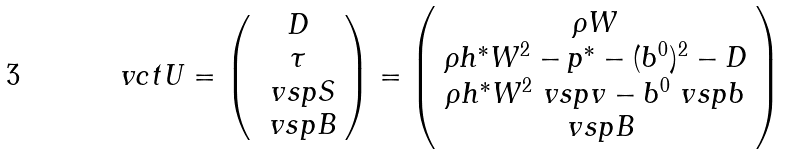<formula> <loc_0><loc_0><loc_500><loc_500>\ v c t { U } = \left ( \begin{array} { c } D \\ \tau \\ \ v s p { S } \\ \ v s p { B } \end{array} \right ) = \left ( \begin{array} { c } \rho W \\ \rho h ^ { * } W ^ { 2 } - p ^ { * } - ( b ^ { 0 } ) ^ { 2 } - D \\ \rho h ^ { * } W ^ { 2 } \ v s p { v } - b ^ { 0 } \ v s p { b } \\ \ v s p { B } \end{array} \right )</formula> 